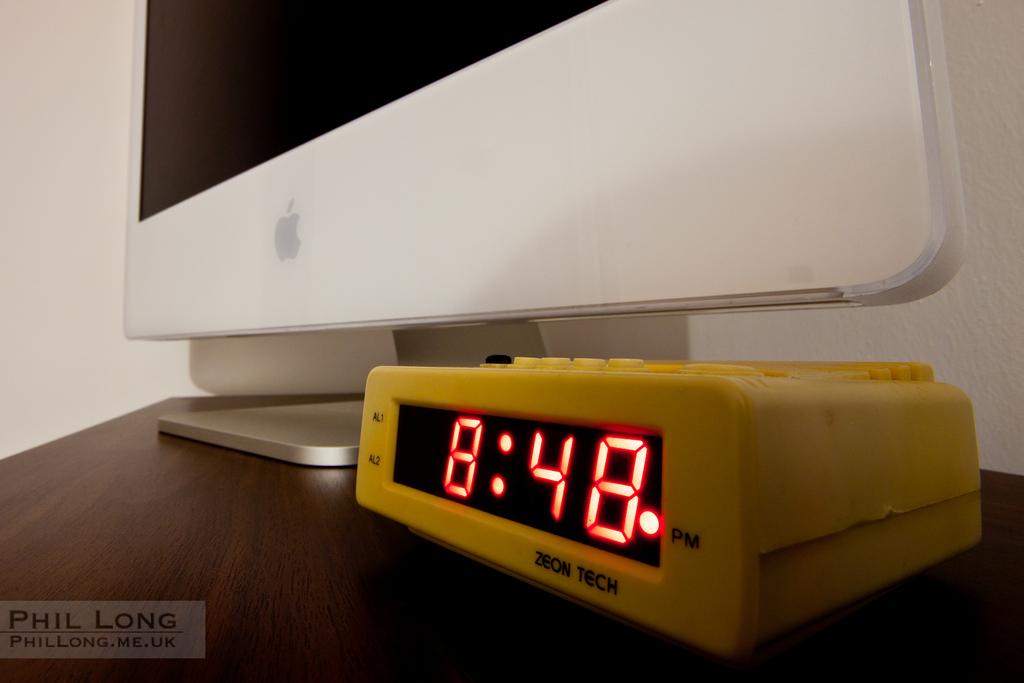What time is displayed on the lcd clock?
Give a very brief answer. 8:48. Which company makes this bright yellow clock?
Provide a succinct answer. Zeon tech. 